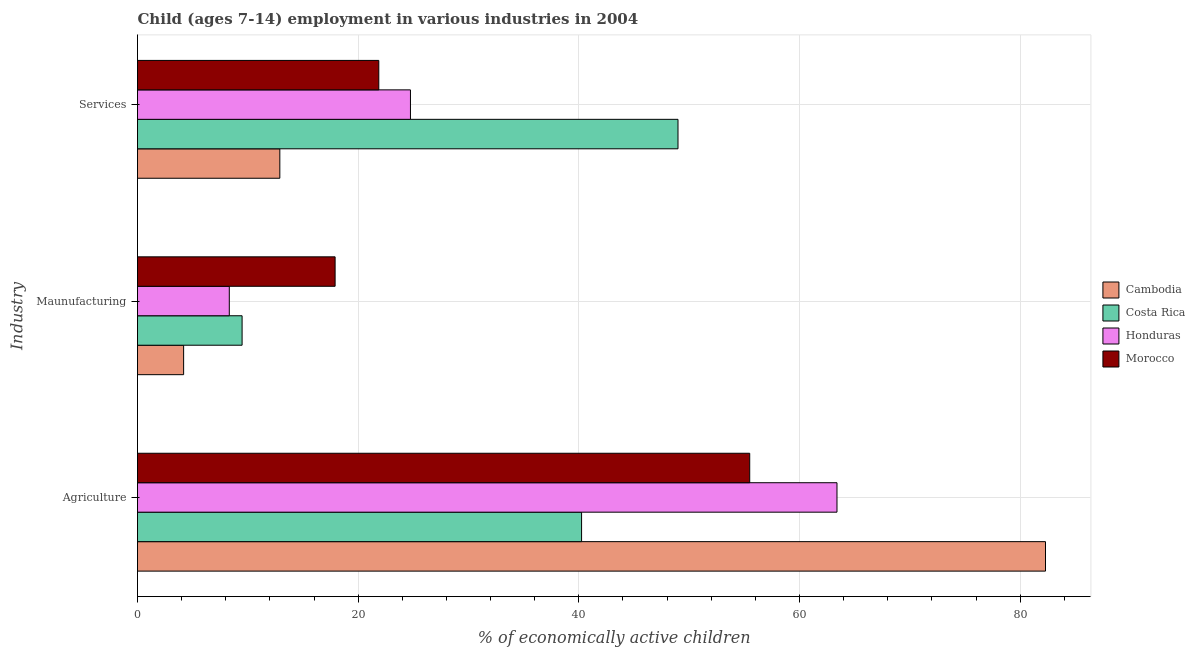How many groups of bars are there?
Your answer should be very brief. 3. How many bars are there on the 1st tick from the bottom?
Give a very brief answer. 4. What is the label of the 2nd group of bars from the top?
Ensure brevity in your answer.  Maunufacturing. What is the percentage of economically active children in agriculture in Honduras?
Offer a terse response. 63.4. Across all countries, what is the maximum percentage of economically active children in manufacturing?
Provide a short and direct response. 17.91. Across all countries, what is the minimum percentage of economically active children in agriculture?
Your response must be concise. 40.25. In which country was the percentage of economically active children in services maximum?
Offer a very short reply. Costa Rica. In which country was the percentage of economically active children in services minimum?
Make the answer very short. Cambodia. What is the total percentage of economically active children in agriculture in the graph?
Offer a terse response. 241.44. What is the difference between the percentage of economically active children in services in Morocco and that in Costa Rica?
Give a very brief answer. -27.12. What is the difference between the percentage of economically active children in agriculture in Morocco and the percentage of economically active children in services in Cambodia?
Provide a succinct answer. 42.59. What is the average percentage of economically active children in services per country?
Your response must be concise. 27.12. What is the difference between the percentage of economically active children in services and percentage of economically active children in manufacturing in Cambodia?
Ensure brevity in your answer.  8.72. In how many countries, is the percentage of economically active children in manufacturing greater than 52 %?
Provide a succinct answer. 0. What is the ratio of the percentage of economically active children in agriculture in Morocco to that in Cambodia?
Provide a succinct answer. 0.67. What is the difference between the highest and the second highest percentage of economically active children in services?
Make the answer very short. 24.25. What is the difference between the highest and the lowest percentage of economically active children in agriculture?
Give a very brief answer. 42.05. Is the sum of the percentage of economically active children in agriculture in Morocco and Honduras greater than the maximum percentage of economically active children in manufacturing across all countries?
Offer a very short reply. Yes. What does the 1st bar from the top in Maunufacturing represents?
Offer a terse response. Morocco. Is it the case that in every country, the sum of the percentage of economically active children in agriculture and percentage of economically active children in manufacturing is greater than the percentage of economically active children in services?
Provide a succinct answer. Yes. How many bars are there?
Provide a short and direct response. 12. Are all the bars in the graph horizontal?
Offer a very short reply. Yes. Are the values on the major ticks of X-axis written in scientific E-notation?
Your answer should be very brief. No. Does the graph contain any zero values?
Offer a terse response. No. Where does the legend appear in the graph?
Make the answer very short. Center right. What is the title of the graph?
Your answer should be compact. Child (ages 7-14) employment in various industries in 2004. What is the label or title of the X-axis?
Provide a succinct answer. % of economically active children. What is the label or title of the Y-axis?
Your answer should be compact. Industry. What is the % of economically active children in Cambodia in Agriculture?
Make the answer very short. 82.3. What is the % of economically active children in Costa Rica in Agriculture?
Your response must be concise. 40.25. What is the % of economically active children of Honduras in Agriculture?
Provide a short and direct response. 63.4. What is the % of economically active children in Morocco in Agriculture?
Offer a terse response. 55.49. What is the % of economically active children of Cambodia in Maunufacturing?
Offer a very short reply. 4.18. What is the % of economically active children in Costa Rica in Maunufacturing?
Provide a succinct answer. 9.48. What is the % of economically active children in Honduras in Maunufacturing?
Keep it short and to the point. 8.32. What is the % of economically active children in Morocco in Maunufacturing?
Give a very brief answer. 17.91. What is the % of economically active children in Cambodia in Services?
Offer a terse response. 12.9. What is the % of economically active children in Costa Rica in Services?
Provide a succinct answer. 48.99. What is the % of economically active children of Honduras in Services?
Offer a terse response. 24.74. What is the % of economically active children in Morocco in Services?
Offer a very short reply. 21.87. Across all Industry, what is the maximum % of economically active children in Cambodia?
Provide a succinct answer. 82.3. Across all Industry, what is the maximum % of economically active children in Costa Rica?
Make the answer very short. 48.99. Across all Industry, what is the maximum % of economically active children in Honduras?
Provide a short and direct response. 63.4. Across all Industry, what is the maximum % of economically active children of Morocco?
Your answer should be very brief. 55.49. Across all Industry, what is the minimum % of economically active children of Cambodia?
Your response must be concise. 4.18. Across all Industry, what is the minimum % of economically active children of Costa Rica?
Make the answer very short. 9.48. Across all Industry, what is the minimum % of economically active children in Honduras?
Keep it short and to the point. 8.32. Across all Industry, what is the minimum % of economically active children of Morocco?
Your answer should be compact. 17.91. What is the total % of economically active children of Cambodia in the graph?
Your answer should be very brief. 99.38. What is the total % of economically active children in Costa Rica in the graph?
Offer a very short reply. 98.72. What is the total % of economically active children in Honduras in the graph?
Offer a terse response. 96.46. What is the total % of economically active children of Morocco in the graph?
Ensure brevity in your answer.  95.27. What is the difference between the % of economically active children of Cambodia in Agriculture and that in Maunufacturing?
Your answer should be compact. 78.12. What is the difference between the % of economically active children of Costa Rica in Agriculture and that in Maunufacturing?
Provide a short and direct response. 30.77. What is the difference between the % of economically active children in Honduras in Agriculture and that in Maunufacturing?
Your response must be concise. 55.08. What is the difference between the % of economically active children of Morocco in Agriculture and that in Maunufacturing?
Offer a terse response. 37.58. What is the difference between the % of economically active children in Cambodia in Agriculture and that in Services?
Your answer should be compact. 69.4. What is the difference between the % of economically active children of Costa Rica in Agriculture and that in Services?
Your response must be concise. -8.74. What is the difference between the % of economically active children of Honduras in Agriculture and that in Services?
Give a very brief answer. 38.66. What is the difference between the % of economically active children in Morocco in Agriculture and that in Services?
Give a very brief answer. 33.62. What is the difference between the % of economically active children in Cambodia in Maunufacturing and that in Services?
Your answer should be very brief. -8.72. What is the difference between the % of economically active children of Costa Rica in Maunufacturing and that in Services?
Offer a very short reply. -39.51. What is the difference between the % of economically active children of Honduras in Maunufacturing and that in Services?
Provide a succinct answer. -16.42. What is the difference between the % of economically active children in Morocco in Maunufacturing and that in Services?
Provide a succinct answer. -3.96. What is the difference between the % of economically active children in Cambodia in Agriculture and the % of economically active children in Costa Rica in Maunufacturing?
Offer a terse response. 72.82. What is the difference between the % of economically active children in Cambodia in Agriculture and the % of economically active children in Honduras in Maunufacturing?
Ensure brevity in your answer.  73.98. What is the difference between the % of economically active children of Cambodia in Agriculture and the % of economically active children of Morocco in Maunufacturing?
Keep it short and to the point. 64.39. What is the difference between the % of economically active children of Costa Rica in Agriculture and the % of economically active children of Honduras in Maunufacturing?
Make the answer very short. 31.93. What is the difference between the % of economically active children of Costa Rica in Agriculture and the % of economically active children of Morocco in Maunufacturing?
Keep it short and to the point. 22.34. What is the difference between the % of economically active children in Honduras in Agriculture and the % of economically active children in Morocco in Maunufacturing?
Your answer should be compact. 45.49. What is the difference between the % of economically active children in Cambodia in Agriculture and the % of economically active children in Costa Rica in Services?
Offer a very short reply. 33.31. What is the difference between the % of economically active children in Cambodia in Agriculture and the % of economically active children in Honduras in Services?
Your response must be concise. 57.56. What is the difference between the % of economically active children in Cambodia in Agriculture and the % of economically active children in Morocco in Services?
Your answer should be compact. 60.43. What is the difference between the % of economically active children of Costa Rica in Agriculture and the % of economically active children of Honduras in Services?
Ensure brevity in your answer.  15.51. What is the difference between the % of economically active children in Costa Rica in Agriculture and the % of economically active children in Morocco in Services?
Offer a very short reply. 18.38. What is the difference between the % of economically active children in Honduras in Agriculture and the % of economically active children in Morocco in Services?
Make the answer very short. 41.53. What is the difference between the % of economically active children in Cambodia in Maunufacturing and the % of economically active children in Costa Rica in Services?
Your response must be concise. -44.81. What is the difference between the % of economically active children of Cambodia in Maunufacturing and the % of economically active children of Honduras in Services?
Your answer should be very brief. -20.56. What is the difference between the % of economically active children of Cambodia in Maunufacturing and the % of economically active children of Morocco in Services?
Provide a short and direct response. -17.69. What is the difference between the % of economically active children in Costa Rica in Maunufacturing and the % of economically active children in Honduras in Services?
Your answer should be compact. -15.26. What is the difference between the % of economically active children of Costa Rica in Maunufacturing and the % of economically active children of Morocco in Services?
Offer a terse response. -12.39. What is the difference between the % of economically active children in Honduras in Maunufacturing and the % of economically active children in Morocco in Services?
Offer a terse response. -13.55. What is the average % of economically active children in Cambodia per Industry?
Keep it short and to the point. 33.13. What is the average % of economically active children of Costa Rica per Industry?
Keep it short and to the point. 32.91. What is the average % of economically active children of Honduras per Industry?
Your answer should be compact. 32.15. What is the average % of economically active children in Morocco per Industry?
Provide a short and direct response. 31.76. What is the difference between the % of economically active children of Cambodia and % of economically active children of Costa Rica in Agriculture?
Provide a succinct answer. 42.05. What is the difference between the % of economically active children of Cambodia and % of economically active children of Morocco in Agriculture?
Provide a short and direct response. 26.81. What is the difference between the % of economically active children in Costa Rica and % of economically active children in Honduras in Agriculture?
Your answer should be compact. -23.15. What is the difference between the % of economically active children in Costa Rica and % of economically active children in Morocco in Agriculture?
Your answer should be compact. -15.24. What is the difference between the % of economically active children in Honduras and % of economically active children in Morocco in Agriculture?
Provide a short and direct response. 7.91. What is the difference between the % of economically active children of Cambodia and % of economically active children of Costa Rica in Maunufacturing?
Offer a very short reply. -5.3. What is the difference between the % of economically active children of Cambodia and % of economically active children of Honduras in Maunufacturing?
Your answer should be compact. -4.14. What is the difference between the % of economically active children in Cambodia and % of economically active children in Morocco in Maunufacturing?
Make the answer very short. -13.73. What is the difference between the % of economically active children in Costa Rica and % of economically active children in Honduras in Maunufacturing?
Ensure brevity in your answer.  1.16. What is the difference between the % of economically active children of Costa Rica and % of economically active children of Morocco in Maunufacturing?
Your answer should be compact. -8.43. What is the difference between the % of economically active children of Honduras and % of economically active children of Morocco in Maunufacturing?
Provide a short and direct response. -9.59. What is the difference between the % of economically active children in Cambodia and % of economically active children in Costa Rica in Services?
Ensure brevity in your answer.  -36.09. What is the difference between the % of economically active children in Cambodia and % of economically active children in Honduras in Services?
Provide a short and direct response. -11.84. What is the difference between the % of economically active children in Cambodia and % of economically active children in Morocco in Services?
Make the answer very short. -8.97. What is the difference between the % of economically active children of Costa Rica and % of economically active children of Honduras in Services?
Offer a very short reply. 24.25. What is the difference between the % of economically active children in Costa Rica and % of economically active children in Morocco in Services?
Offer a terse response. 27.12. What is the difference between the % of economically active children of Honduras and % of economically active children of Morocco in Services?
Offer a terse response. 2.87. What is the ratio of the % of economically active children of Cambodia in Agriculture to that in Maunufacturing?
Your answer should be compact. 19.69. What is the ratio of the % of economically active children of Costa Rica in Agriculture to that in Maunufacturing?
Offer a terse response. 4.25. What is the ratio of the % of economically active children in Honduras in Agriculture to that in Maunufacturing?
Keep it short and to the point. 7.62. What is the ratio of the % of economically active children of Morocco in Agriculture to that in Maunufacturing?
Keep it short and to the point. 3.1. What is the ratio of the % of economically active children of Cambodia in Agriculture to that in Services?
Keep it short and to the point. 6.38. What is the ratio of the % of economically active children in Costa Rica in Agriculture to that in Services?
Your answer should be compact. 0.82. What is the ratio of the % of economically active children in Honduras in Agriculture to that in Services?
Provide a succinct answer. 2.56. What is the ratio of the % of economically active children in Morocco in Agriculture to that in Services?
Keep it short and to the point. 2.54. What is the ratio of the % of economically active children in Cambodia in Maunufacturing to that in Services?
Offer a terse response. 0.32. What is the ratio of the % of economically active children of Costa Rica in Maunufacturing to that in Services?
Offer a very short reply. 0.19. What is the ratio of the % of economically active children of Honduras in Maunufacturing to that in Services?
Ensure brevity in your answer.  0.34. What is the ratio of the % of economically active children of Morocco in Maunufacturing to that in Services?
Offer a terse response. 0.82. What is the difference between the highest and the second highest % of economically active children of Cambodia?
Your answer should be compact. 69.4. What is the difference between the highest and the second highest % of economically active children of Costa Rica?
Your response must be concise. 8.74. What is the difference between the highest and the second highest % of economically active children in Honduras?
Offer a terse response. 38.66. What is the difference between the highest and the second highest % of economically active children of Morocco?
Make the answer very short. 33.62. What is the difference between the highest and the lowest % of economically active children in Cambodia?
Make the answer very short. 78.12. What is the difference between the highest and the lowest % of economically active children in Costa Rica?
Your response must be concise. 39.51. What is the difference between the highest and the lowest % of economically active children in Honduras?
Provide a succinct answer. 55.08. What is the difference between the highest and the lowest % of economically active children of Morocco?
Keep it short and to the point. 37.58. 